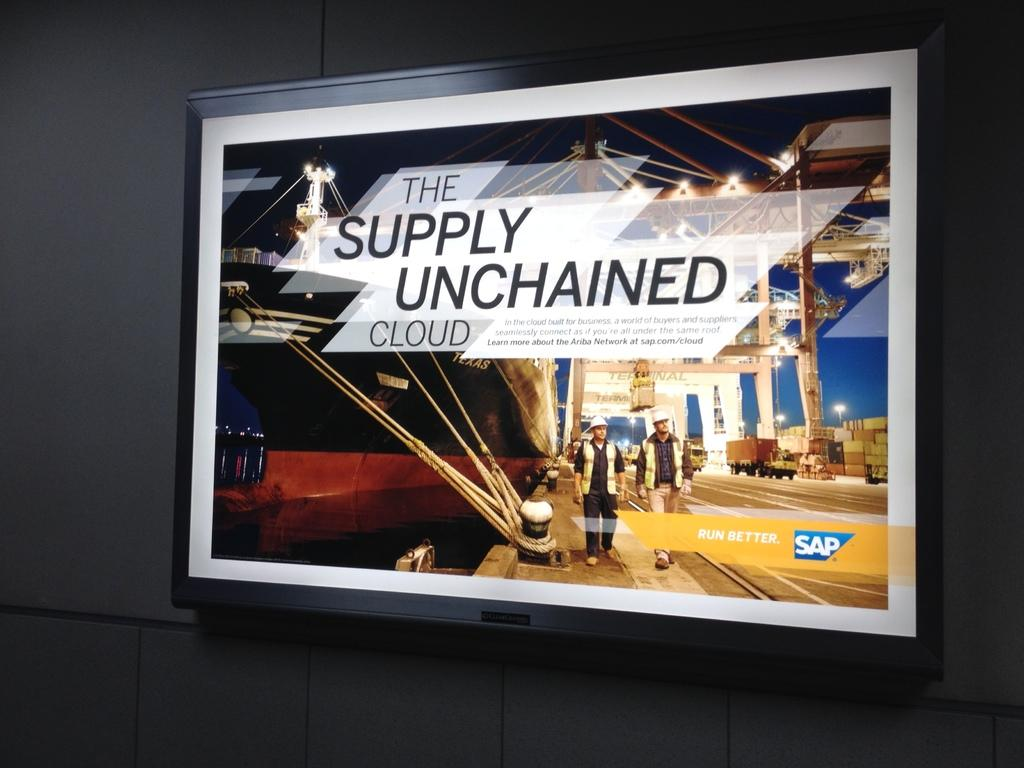<image>
Summarize the visual content of the image. The supply unchained cloud run better sap sign on a wall 